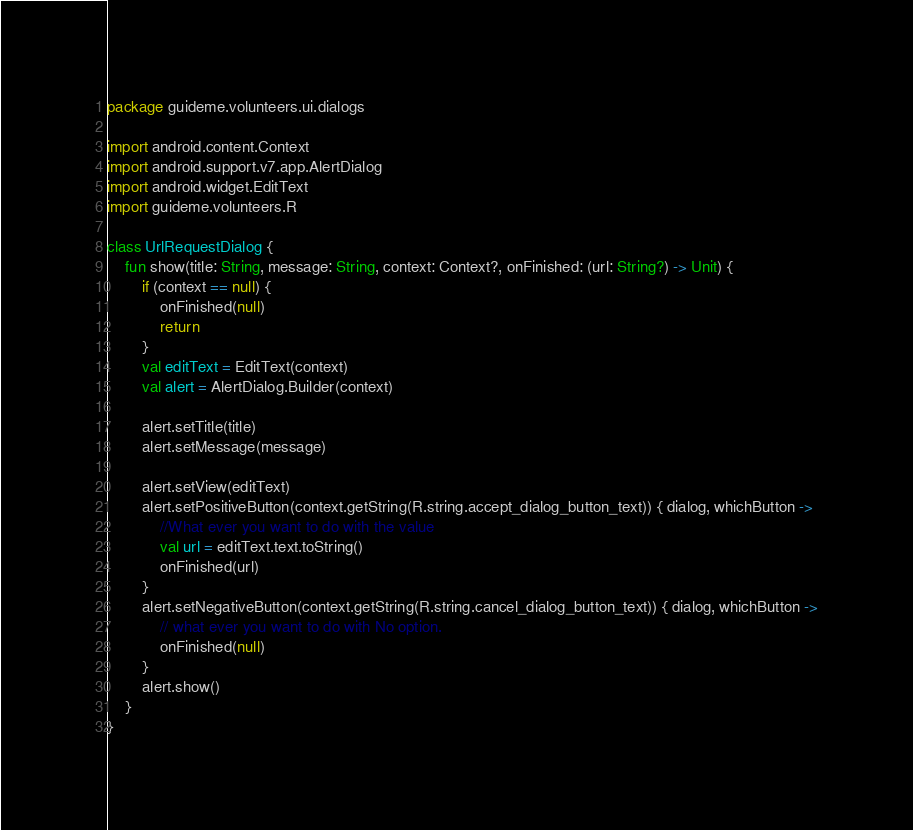<code> <loc_0><loc_0><loc_500><loc_500><_Kotlin_>package guideme.volunteers.ui.dialogs

import android.content.Context
import android.support.v7.app.AlertDialog
import android.widget.EditText
import guideme.volunteers.R

class UrlRequestDialog {
    fun show(title: String, message: String, context: Context?, onFinished: (url: String?) -> Unit) {
        if (context == null) {
            onFinished(null)
            return
        }
        val editText = EditText(context)
        val alert = AlertDialog.Builder(context)

        alert.setTitle(title)
        alert.setMessage(message)

        alert.setView(editText)
        alert.setPositiveButton(context.getString(R.string.accept_dialog_button_text)) { dialog, whichButton ->
            //What ever you want to do with the value
            val url = editText.text.toString()
            onFinished(url)
        }
        alert.setNegativeButton(context.getString(R.string.cancel_dialog_button_text)) { dialog, whichButton ->
            // what ever you want to do with No option.
            onFinished(null)
        }
        alert.show()
    }
}
</code> 